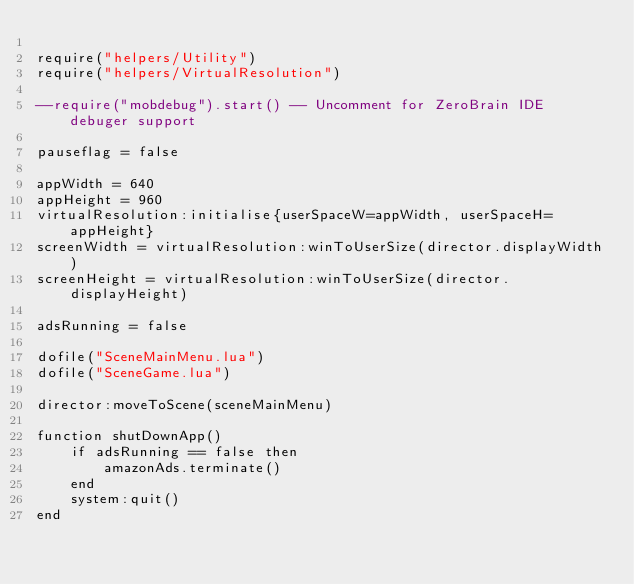<code> <loc_0><loc_0><loc_500><loc_500><_Lua_>
require("helpers/Utility")
require("helpers/VirtualResolution")

--require("mobdebug").start() -- Uncomment for ZeroBrain IDE debuger support

pauseflag = false

appWidth = 640
appHeight = 960
virtualResolution:initialise{userSpaceW=appWidth, userSpaceH=appHeight}
screenWidth = virtualResolution:winToUserSize(director.displayWidth)
screenHeight = virtualResolution:winToUserSize(director.displayHeight)

adsRunning = false

dofile("SceneMainMenu.lua")
dofile("SceneGame.lua")

director:moveToScene(sceneMainMenu)

function shutDownApp()
    if adsRunning == false then
        amazonAds.terminate()
    end
    system:quit()
end
</code> 